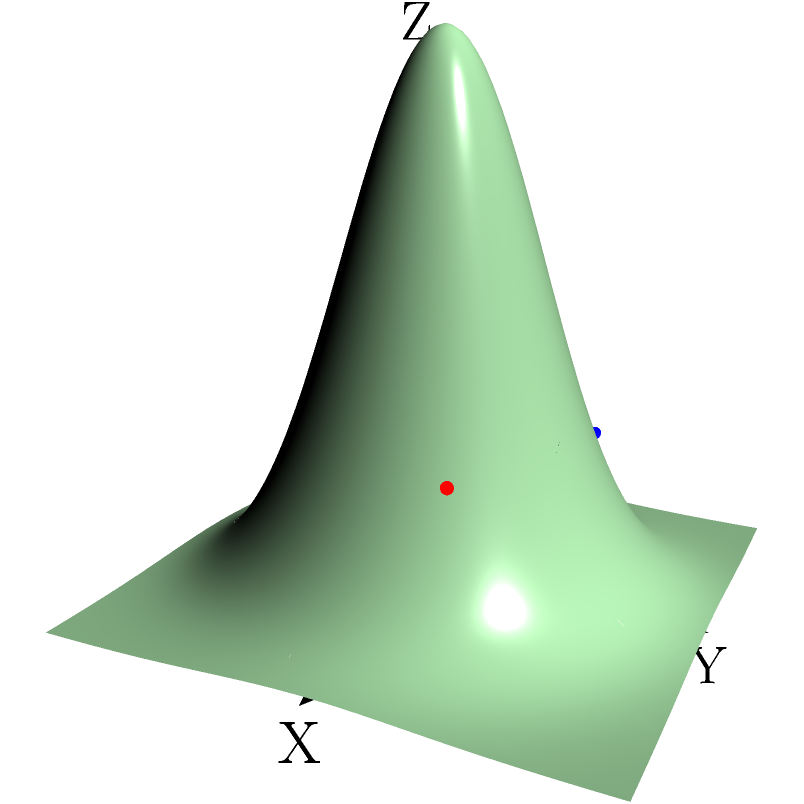Given the 3D coordinate system representing brain activity data, where the X and Y axes represent spatial coordinates and the Z-axis represents neural activation intensity, identify the coordinates of the point with the highest activation intensity among the three colored points (red, blue, and green). To solve this problem, we need to follow these steps:

1. Identify the coordinates of each colored point:
   - Red point: $(1, 0.5, z_1)$
   - Blue point: $(-0.5, 1, z_2)$
   - Green point: $(0, -1, z_3)$

2. Compare the Z-coordinates (activation intensities) of these points:
   - The Z-coordinate is determined by the function $f(x,y) = 5e^{-x^2-y^2}$

3. Calculate the Z-coordinate for each point:
   - Red point: $z_1 = 5e^{-(1)^2-(0.5)^2} \approx 2.10$
   - Blue point: $z_2 = 5e^{-(-0.5)^2-(1)^2} \approx 1.84$
   - Green point: $z_3 = 5e^{-(0)^2-(-1)^2} \approx 1.84$

4. Compare the Z-values:
   $z_1 > z_2 = z_3$

5. Identify the point with the highest Z-value:
   The red point has the highest Z-value, thus the highest activation intensity.

Therefore, the coordinates of the point with the highest activation intensity are $(1, 0.5, 2.10)$, which corresponds to the red point.
Answer: $(1, 0.5, 2.10)$ 